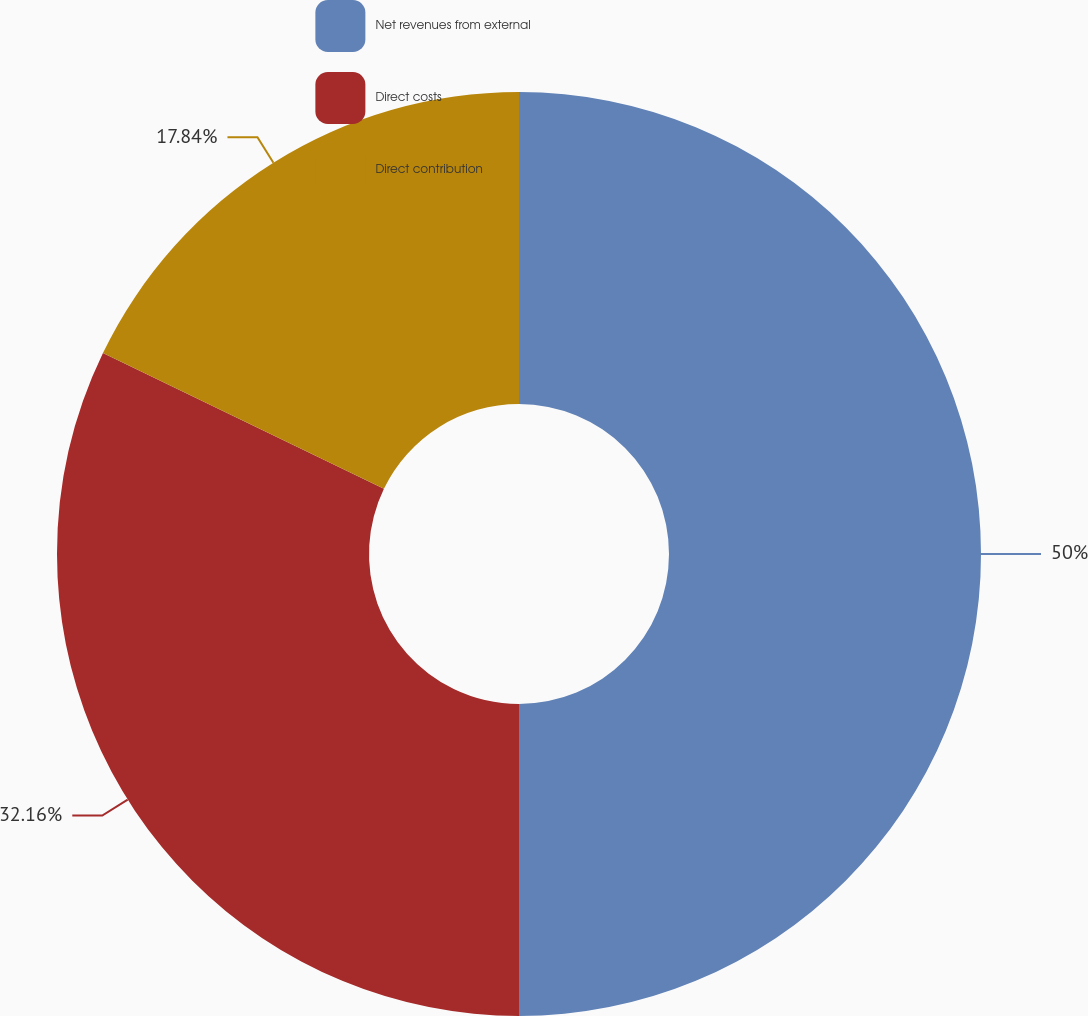Convert chart. <chart><loc_0><loc_0><loc_500><loc_500><pie_chart><fcel>Net revenues from external<fcel>Direct costs<fcel>Direct contribution<nl><fcel>50.0%<fcel>32.16%<fcel>17.84%<nl></chart> 